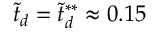Convert formula to latex. <formula><loc_0><loc_0><loc_500><loc_500>\tilde { t } _ { d } = \tilde { t } _ { d } ^ { * * } \approx 0 . 1 5</formula> 